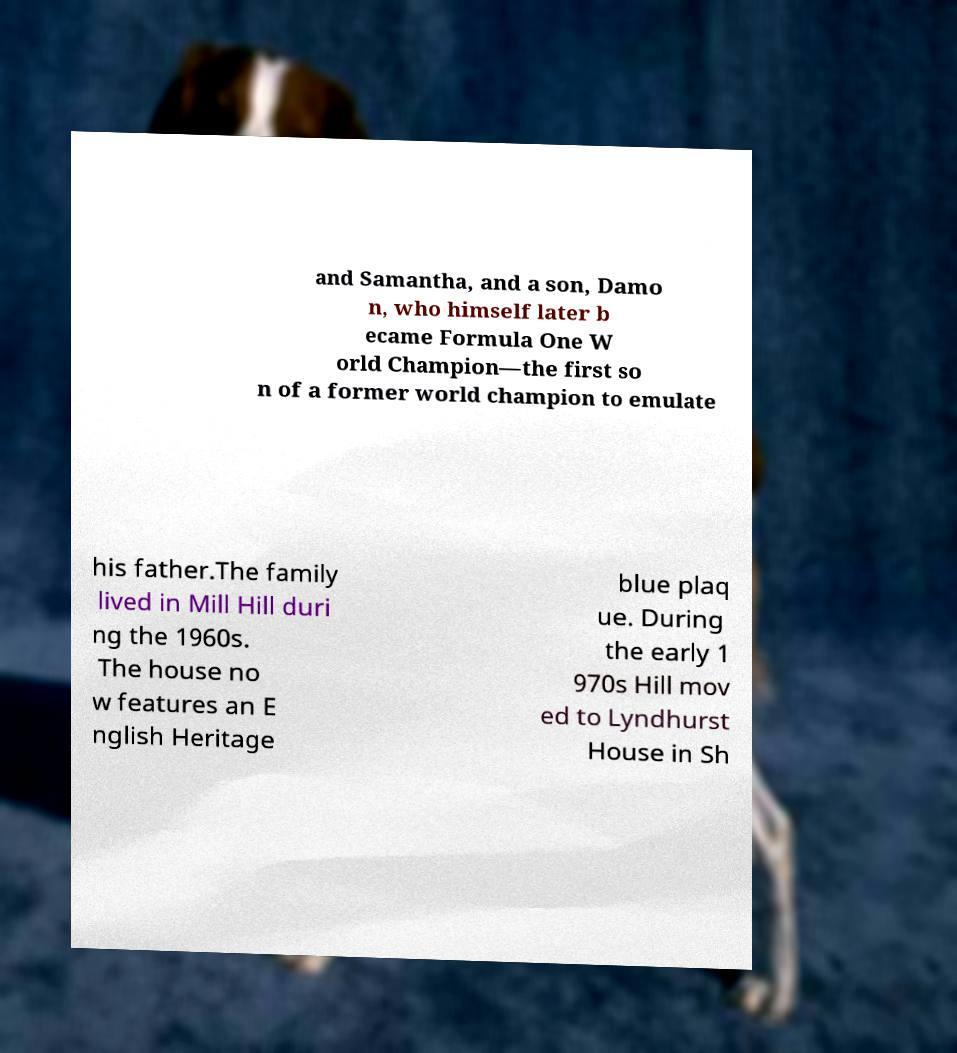Could you extract and type out the text from this image? and Samantha, and a son, Damo n, who himself later b ecame Formula One W orld Champion—the first so n of a former world champion to emulate his father.The family lived in Mill Hill duri ng the 1960s. The house no w features an E nglish Heritage blue plaq ue. During the early 1 970s Hill mov ed to Lyndhurst House in Sh 